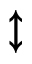<formula> <loc_0><loc_0><loc_500><loc_500>\updownarrow</formula> 